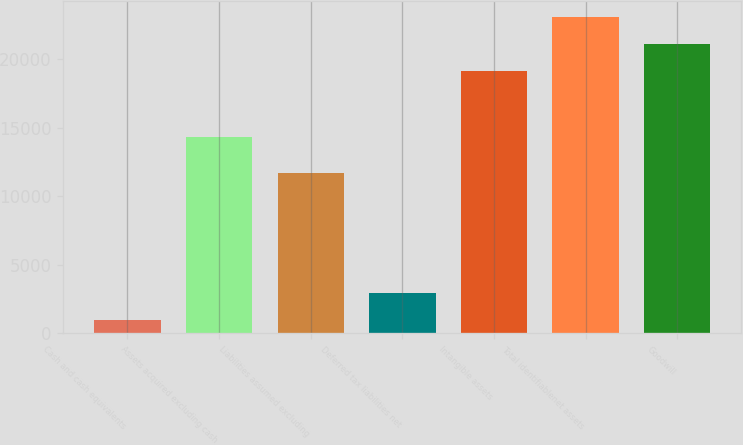Convert chart. <chart><loc_0><loc_0><loc_500><loc_500><bar_chart><fcel>Cash and cash equivalents<fcel>Assets acquired excluding cash<fcel>Liabilities assumed excluding<fcel>Deferred tax liabilities net<fcel>Intangible assets<fcel>Total identifiablenet assets<fcel>Goodwill<nl><fcel>969<fcel>14353<fcel>11669<fcel>2951<fcel>19140<fcel>23104<fcel>21122<nl></chart> 